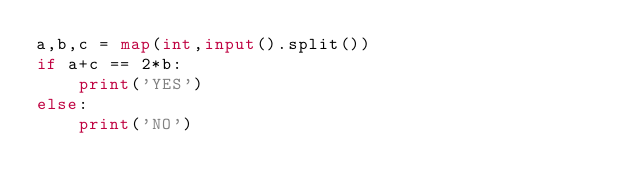Convert code to text. <code><loc_0><loc_0><loc_500><loc_500><_Python_>a,b,c = map(int,input().split())
if a+c == 2*b:
    print('YES')
else:
    print('NO')</code> 